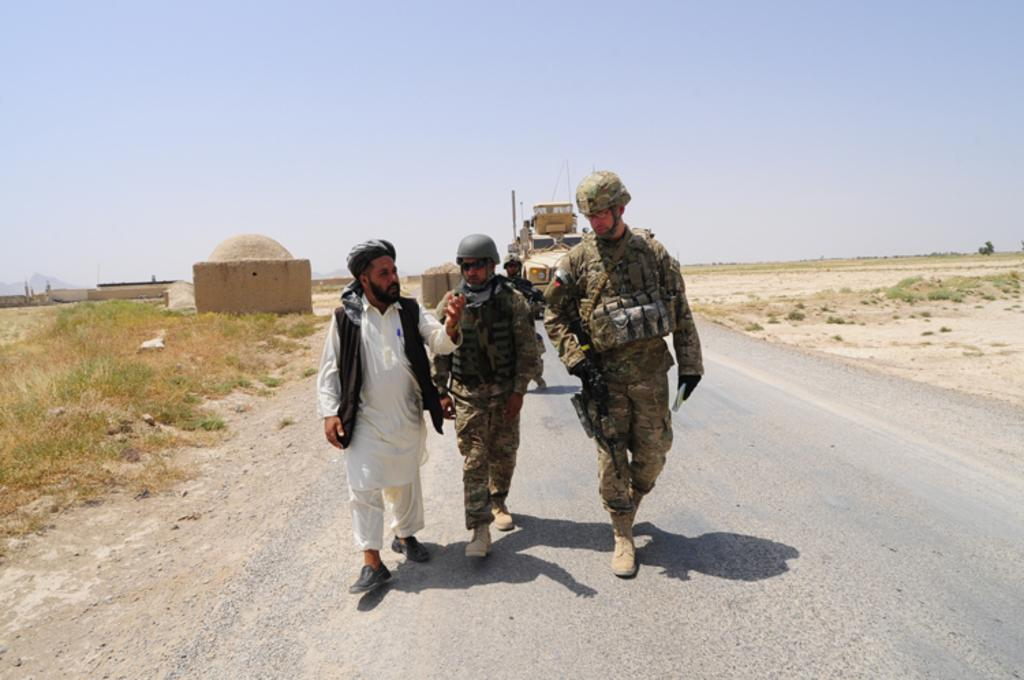How many people are in the image? There are people in the image, but the exact number is not specified. What type of vehicle is present in the image? There is a vehicle in the image, but the specific type is not mentioned. Where are the people and vehicle located? The people and vehicle are on a road in the image. What can be seen in the background of the image? In the background of the image, there is grass, a house, and the sky. What type of wine is being served at the playground in the image? There is no playground or wine present in the image. 